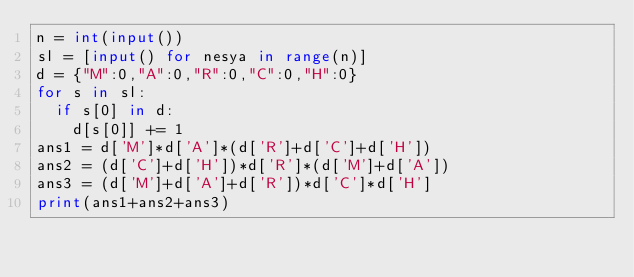Convert code to text. <code><loc_0><loc_0><loc_500><loc_500><_Python_>n = int(input())
sl = [input() for nesya in range(n)]
d = {"M":0,"A":0,"R":0,"C":0,"H":0}
for s in sl:
  if s[0] in d:
    d[s[0]] += 1
ans1 = d['M']*d['A']*(d['R']+d['C']+d['H'])
ans2 = (d['C']+d['H'])*d['R']*(d['M']+d['A'])
ans3 = (d['M']+d['A']+d['R'])*d['C']*d['H']
print(ans1+ans2+ans3)</code> 